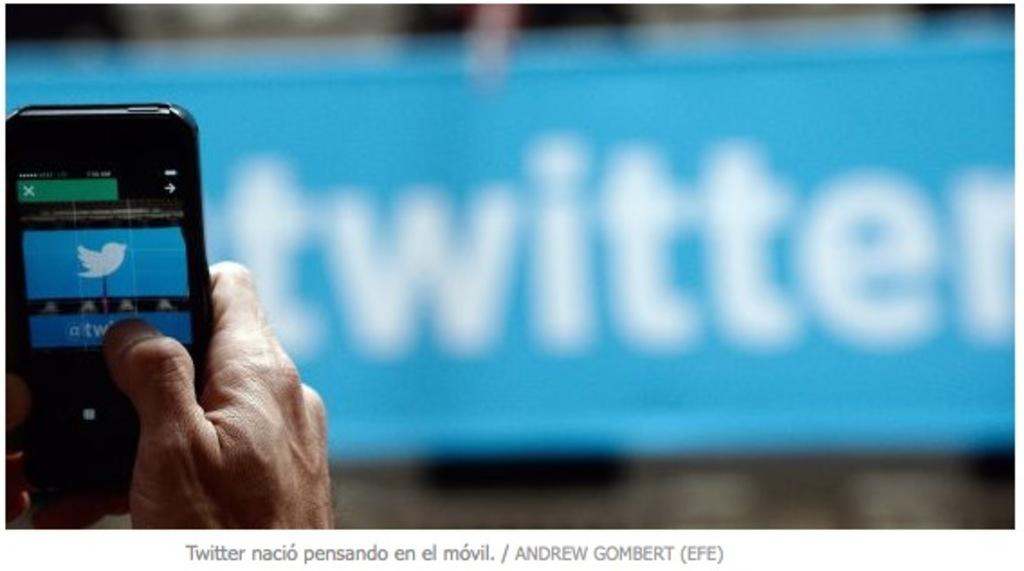<image>
Create a compact narrative representing the image presented. A hand holding a cell phone with the Twitter logo on it with a blue sign in the background that says Twitter on it. 